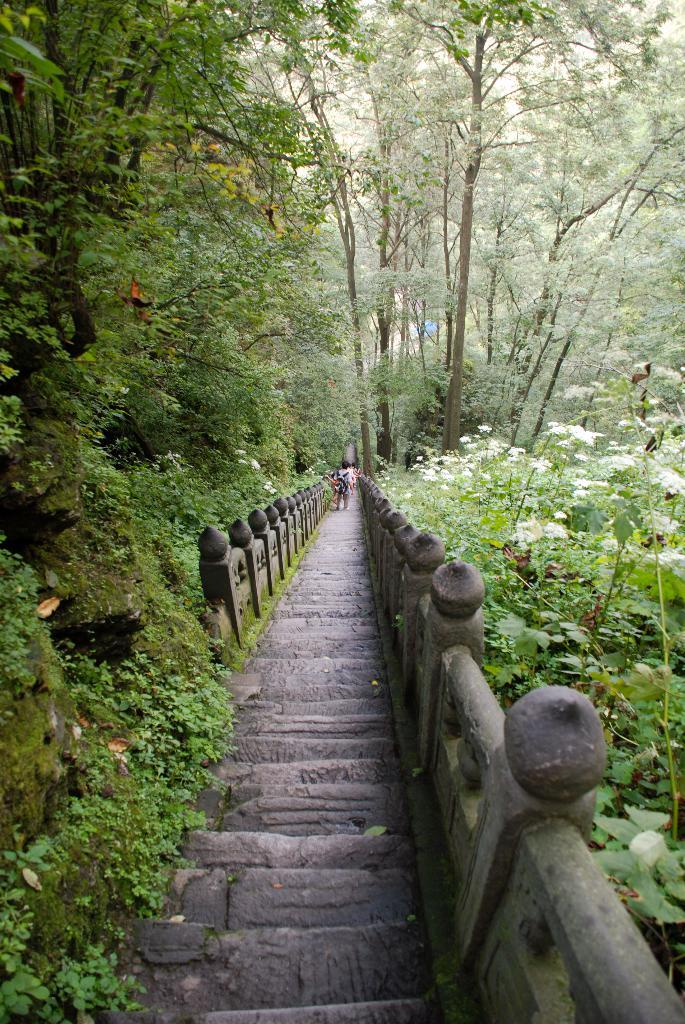What can be seen on the bridge in the image? There are people on the bridge. What type of vegetation is located beside the bridge? There are trees beside the bridge. What type of bait is being used by the people on the bridge? There is no mention of bait or fishing in the image, so it cannot be determined what type of bait might be used. What is the purpose of the bridge in the image? The purpose of the bridge cannot be definitively determined from the image alone, as it could serve various purposes such as connecting two land areas or providing a scenic viewpoint. Are there any cars visible on the bridge in the image? There is no mention of cars or vehicles in the image, so it cannot be determined if any are present. 